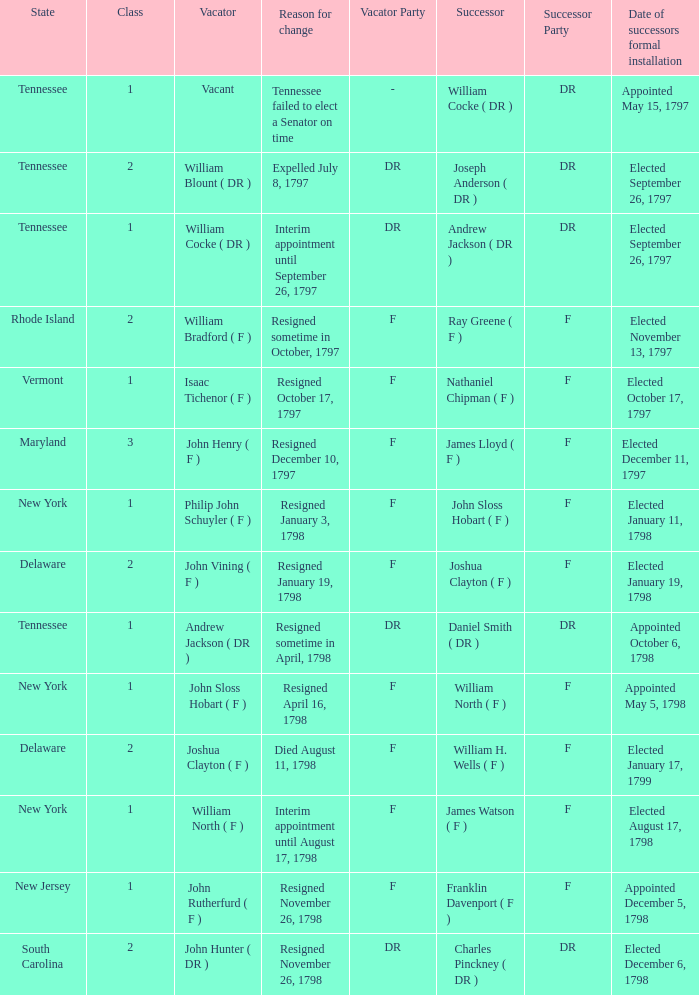What is the total number of successors when the vacator was William North ( F ) 1.0. 